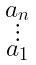<formula> <loc_0><loc_0><loc_500><loc_500>\begin{smallmatrix} a _ { n } \\ \vdots \\ a _ { 1 } \end{smallmatrix}</formula> 